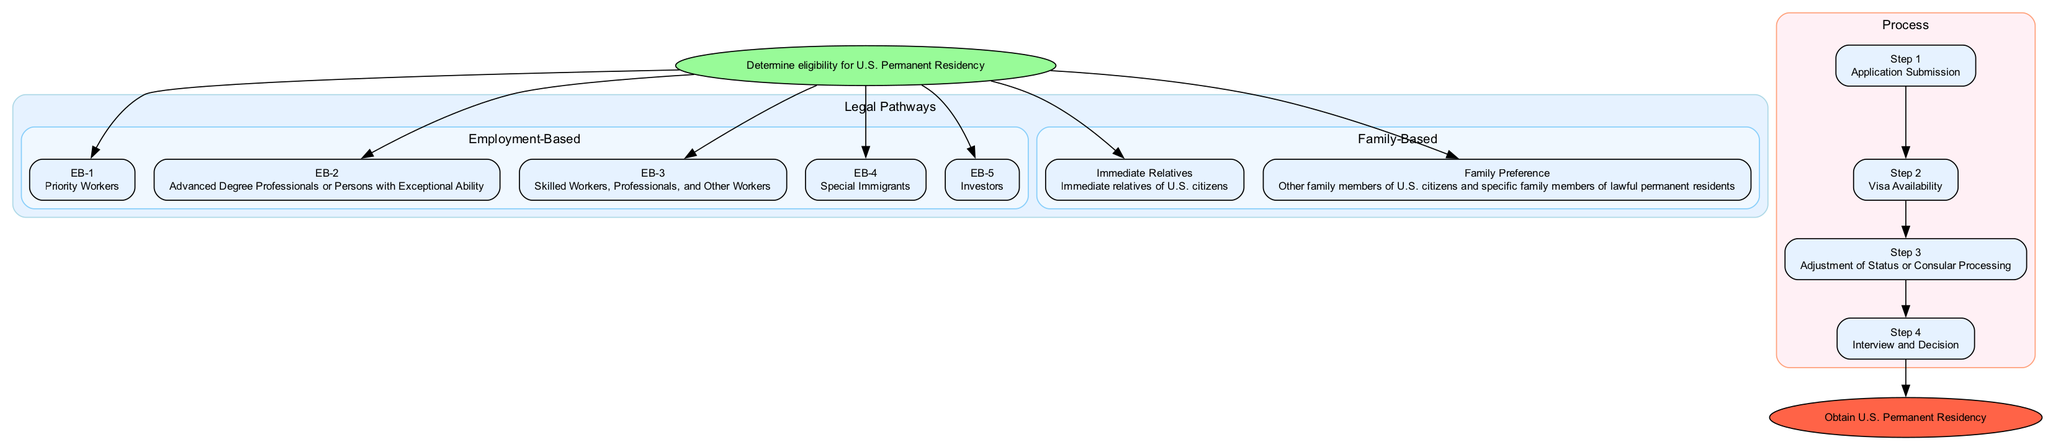What's the starting point of the diagram? The diagram starts with the node labeled "Determine eligibility for U.S. Permanent Residency," which is represented by the "Start" node.
Answer: Determine eligibility for U.S. Permanent Residency How many main pathways are shown for obtaining permanent residency? The diagram shows two main pathways: "Legal Pathways" and "Process." Each of these represents different routes to obtain permanent residency in the U.S.
Answer: 2 What is the description of the EB-3 category? The EB-3 category is described as "Skilled Workers, Professionals, and Other Workers," and it encompasses various worker types based on their skills or qualifications.
Answer: Skilled Workers, Professionals, and Other Workers In which step do applicants attend an interview? Applicants attend an interview in Step 4 of the process after their application has been submitted and processed, as indicated by "Attend Interview" action.
Answer: Step 4 What are the two paths mentioned in Step 3 related to processing? Step 3 outlines two paths for applicants: "Adjustment of Status" for those in the U.S. and "Consular Processing" for those outside the U.S.
Answer: Adjustment of Status and Consular Processing Which type of family member falls under "Immediate Relatives" in the Family-Based pathway? "Spouse of U.S. Citizen" is one of the types of family members defined under "Immediate Relatives" in the Family-Based pathway.
Answer: Spouse of U.S. Citizen How does one track the visa availability? Applicants can track visa availability by monitoring the "Visa Bulletin" in Step 2 of the process, which informs them when a visa becomes available for their category.
Answer: Monitor the Visa Bulletin What is required for EB-5 investors to qualify? EB-5 investors must invest a minimum of $1 million, or $500,000 in targeted employment areas, to qualify for this category, according to the criteria mentioned in the diagram.
Answer: Invest a minimum of $1 million Which family preference category includes siblings of U.S. citizens? The family preference category that includes siblings of U.S. citizens is labeled "F4" in the diagram, which delineates this specific group.
Answer: F4 